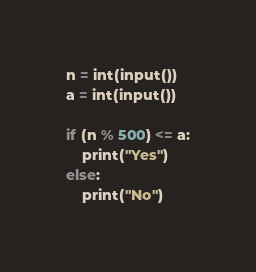Convert code to text. <code><loc_0><loc_0><loc_500><loc_500><_Python_>n = int(input())
a = int(input())

if (n % 500) <= a:
    print("Yes")
else:
    print("No")</code> 